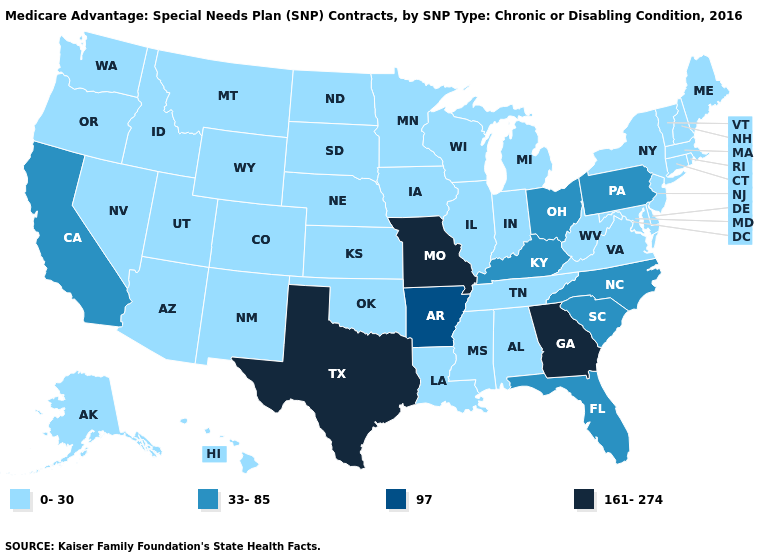How many symbols are there in the legend?
Keep it brief. 4. What is the value of Iowa?
Short answer required. 0-30. Name the states that have a value in the range 0-30?
Write a very short answer. Alaska, Alabama, Arizona, Colorado, Connecticut, Delaware, Hawaii, Iowa, Idaho, Illinois, Indiana, Kansas, Louisiana, Massachusetts, Maryland, Maine, Michigan, Minnesota, Mississippi, Montana, North Dakota, Nebraska, New Hampshire, New Jersey, New Mexico, Nevada, New York, Oklahoma, Oregon, Rhode Island, South Dakota, Tennessee, Utah, Virginia, Vermont, Washington, Wisconsin, West Virginia, Wyoming. What is the value of Oklahoma?
Answer briefly. 0-30. What is the value of Arkansas?
Short answer required. 97. What is the value of Washington?
Be succinct. 0-30. What is the value of Pennsylvania?
Be succinct. 33-85. What is the highest value in the MidWest ?
Concise answer only. 161-274. What is the lowest value in states that border Arizona?
Be succinct. 0-30. Does Louisiana have the lowest value in the USA?
Be succinct. Yes. What is the value of Michigan?
Be succinct. 0-30. Does the first symbol in the legend represent the smallest category?
Quick response, please. Yes. Which states have the lowest value in the West?
Write a very short answer. Alaska, Arizona, Colorado, Hawaii, Idaho, Montana, New Mexico, Nevada, Oregon, Utah, Washington, Wyoming. Does the first symbol in the legend represent the smallest category?
Give a very brief answer. Yes. Name the states that have a value in the range 161-274?
Keep it brief. Georgia, Missouri, Texas. 